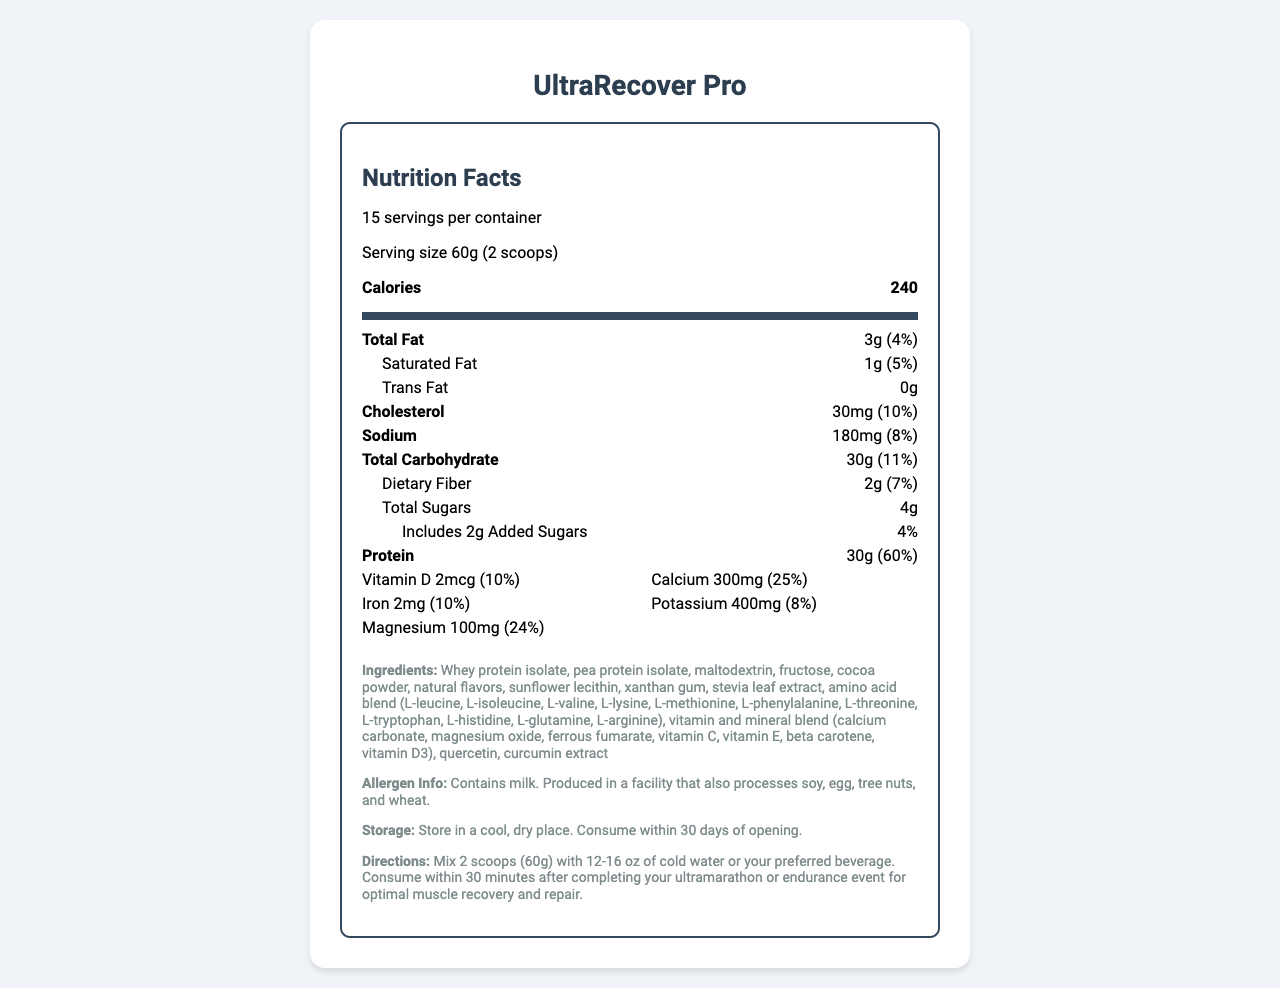what is the serving size of UltraRecover Pro? The serving size is stated at the top of the Nutrition Facts label.
Answer: 60g (2 scoops) how many grams of protein are in one serving? The protein content per serving is clearly listed in the Nutrition Facts section.
Answer: 30g what is the total amount of dietary fiber per serving? The amount of dietary fiber is specified under total carbohydrate in the Nutrition Facts section.
Answer: 2g what is the percentage of daily value for calcium? The daily value percentage for calcium is listed in the vitamins section.
Answer: 25% what is the amount of leucine in the amino acid profile? The amino acid composition lists leucine content as 3000mg.
Answer: 3000mg what is the recommended storage condition for UltraRecover Pro? The storage instructions are mentioned in the additional information section at the bottom of the label.
Answer: Store in a cool, dry place. how many calories are in a single serving of UltraRecover Pro? The calorie content per serving is prominently displayed in the Nutrition Facts section.
Answer: 240 which of the following is NOT listed as an ingredient in UltraRecover Pro? A. Cocoa powder B. Soy protein isolate C. Xanthan gum The ingredient list includes whey protein isolate, pea protein isolate, maltodextrin, fructose, cocoa powder, natural flavors, sunflower lecithin, xanthan gum, stevia leaf extract, and others, but not soy protein isolate.
Answer: B what are the included antioxidants in UltraRecover Pro? The antioxidants section lists these specific compounds.
Answer: vitamin C, vitamin E, beta carotene, quercetin, curcumin does UltraRecover Pro contain any added sugars? The Nutrition Facts label indicates that the product includes 2g of added sugars.
Answer: Yes what are the main electrolytes in UltraRecover Pro? A. Sodium B. Potassium C. Magnesium D. All of the Above The electrolytes section lists sodium, potassium, magnesium, and calcium.
Answer: D is UltraRecover Pro suitable for someone allergic to milk? The allergen information clearly states that the product contains milk.
Answer: No summarize the nutrition information provided for UltraRecover Pro. The summary includes the main nutritional components, servings, specific contents such as protein, amino acids, antioxidants, and storage information.
Answer: UltraRecover Pro is a recovery shake powder designed for post-ultramarathon muscle repair. Each serving is 60g, containing 240 calories, 30g of protein, 3g of total fat, 30g of total carbohydrate, and various vitamins and minerals. It includes an amino acid blend, antioxidants, and electrolytes. The product contains milk and should be stored in a cool, dry place. how does the product help with muscle recovery? The label lists nutritional content but does not detail the specific benefits related to muscle recovery beyond what can be inferred.
Answer: Not enough information 